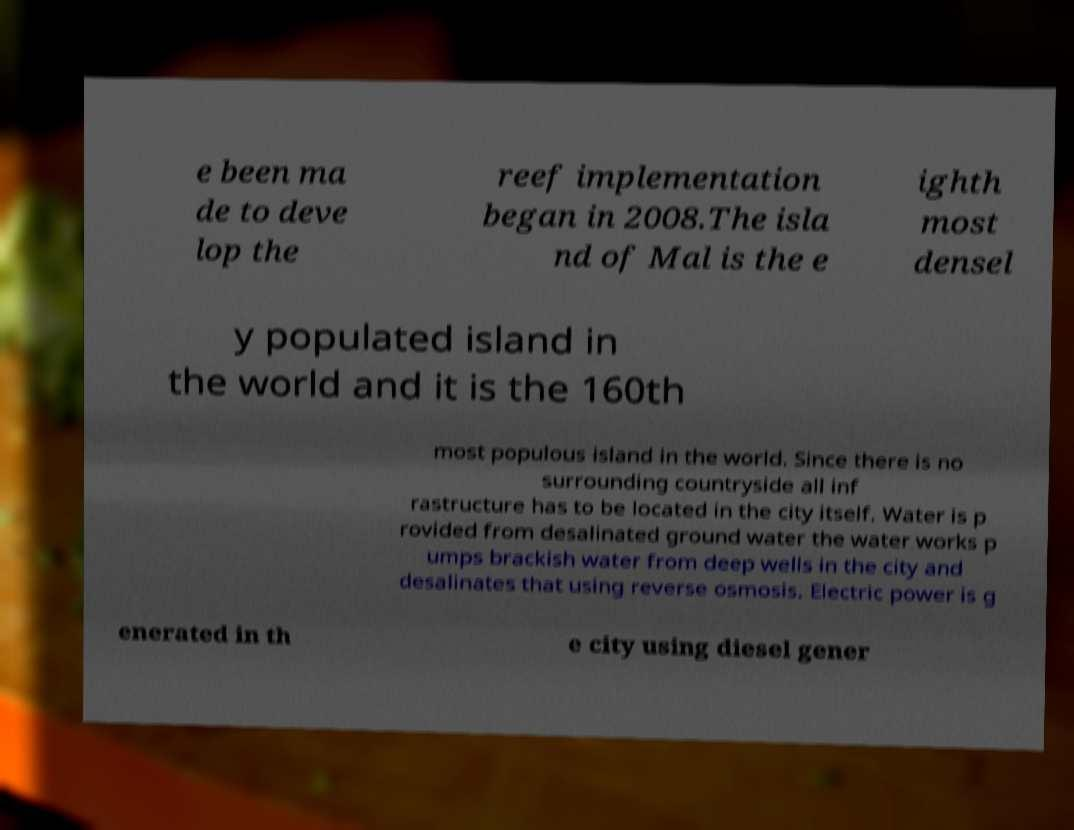Please read and relay the text visible in this image. What does it say? e been ma de to deve lop the reef implementation began in 2008.The isla nd of Mal is the e ighth most densel y populated island in the world and it is the 160th most populous island in the world. Since there is no surrounding countryside all inf rastructure has to be located in the city itself. Water is p rovided from desalinated ground water the water works p umps brackish water from deep wells in the city and desalinates that using reverse osmosis. Electric power is g enerated in th e city using diesel gener 